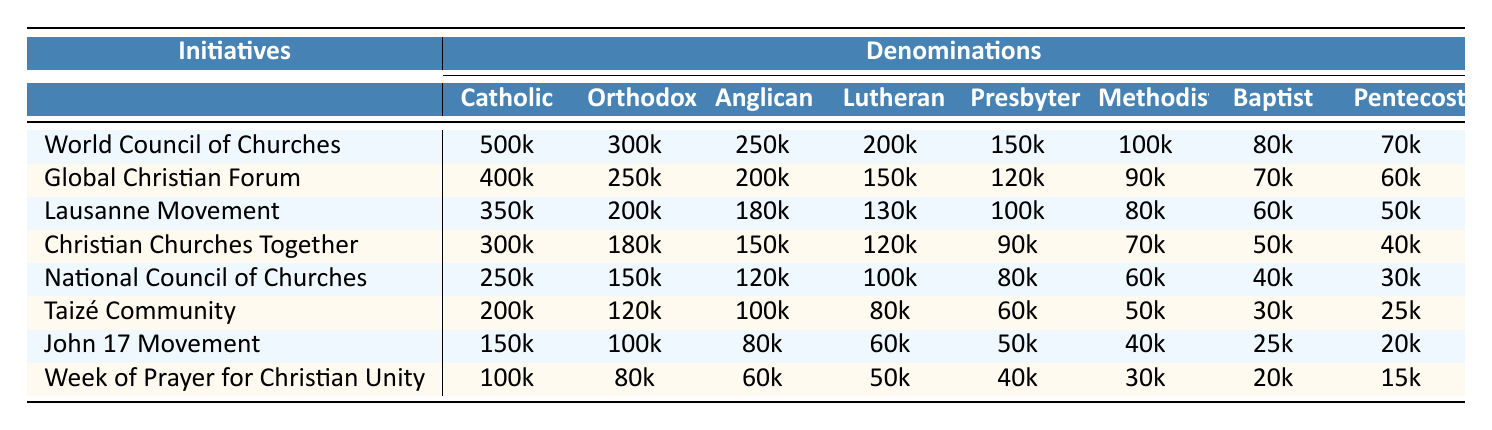What denomination has the highest funding for the World Council of Churches initiative? The table shows the funding amounts for different denominations for various initiatives. For the World Council of Churches, the Catholic denomination has the highest funding of 500k.
Answer: Catholic What is the total funding allocated by the Anglican denomination across all initiatives? To find the total funding for the Anglican denomination, we sum up the values: 250k + 200k + 180k + 150k + 120k + 100k + 80k + 60k = 1,140k.
Answer: 1140k Which initiative received the least funding from the Pentecostal denomination? Looking at the row for the Pentecostal denomination, the least funding was for the Week of Prayer for Christian Unity, which received 15k.
Answer: Week of Prayer for Christian Unity Is the funding for the National Council of Churches greater than that for the Global Christian Forum, for the Lutheran denomination? For the Lutheran denomination, the funding for the National Council of Churches is 100k, and for the Global Christian Forum, it is 150k. Since 100k is less than 150k, the funding for the National Council of Churches is not greater.
Answer: No What is the average funding for the John 17 Movement across all denominations? We calculate the average by adding the funding amounts: 150k + 100k + 80k + 60k + 50k + 40k + 25k + 20k = 525k. Then divide by the number of denominations (8): 525k / 8 = 65.625k.
Answer: 65.625k Which initiative has the highest total funding across all denominations, and what is that total? To find the initiative with the highest total funding, we add the funding for each initiative across all denominations. The totals are: World Council of Churches (1,500k), Global Christian Forum (1,260k), and so forth. The highest is for World Council of Churches: 1,500k.
Answer: World Council of Churches, 1500k How much more funding did the Orthodox denomination allocate to the Taizé Community than to the Week of Prayer for Christian Unity? From the table, the Orthodox funding for Taizé Community is 120k, and for Week of Prayer for Christian Unity is 80k. The difference is 120k - 80k = 40k.
Answer: 40k True or False: The Methodist denomination allocated more funding to the Lausanne Movement than to the John 17 Movement. For the Methodist denomination, the funding is 80k for the Lausanne Movement and 40k for the John 17 Movement. Since 80k is greater than 40k, the statement is true.
Answer: True 